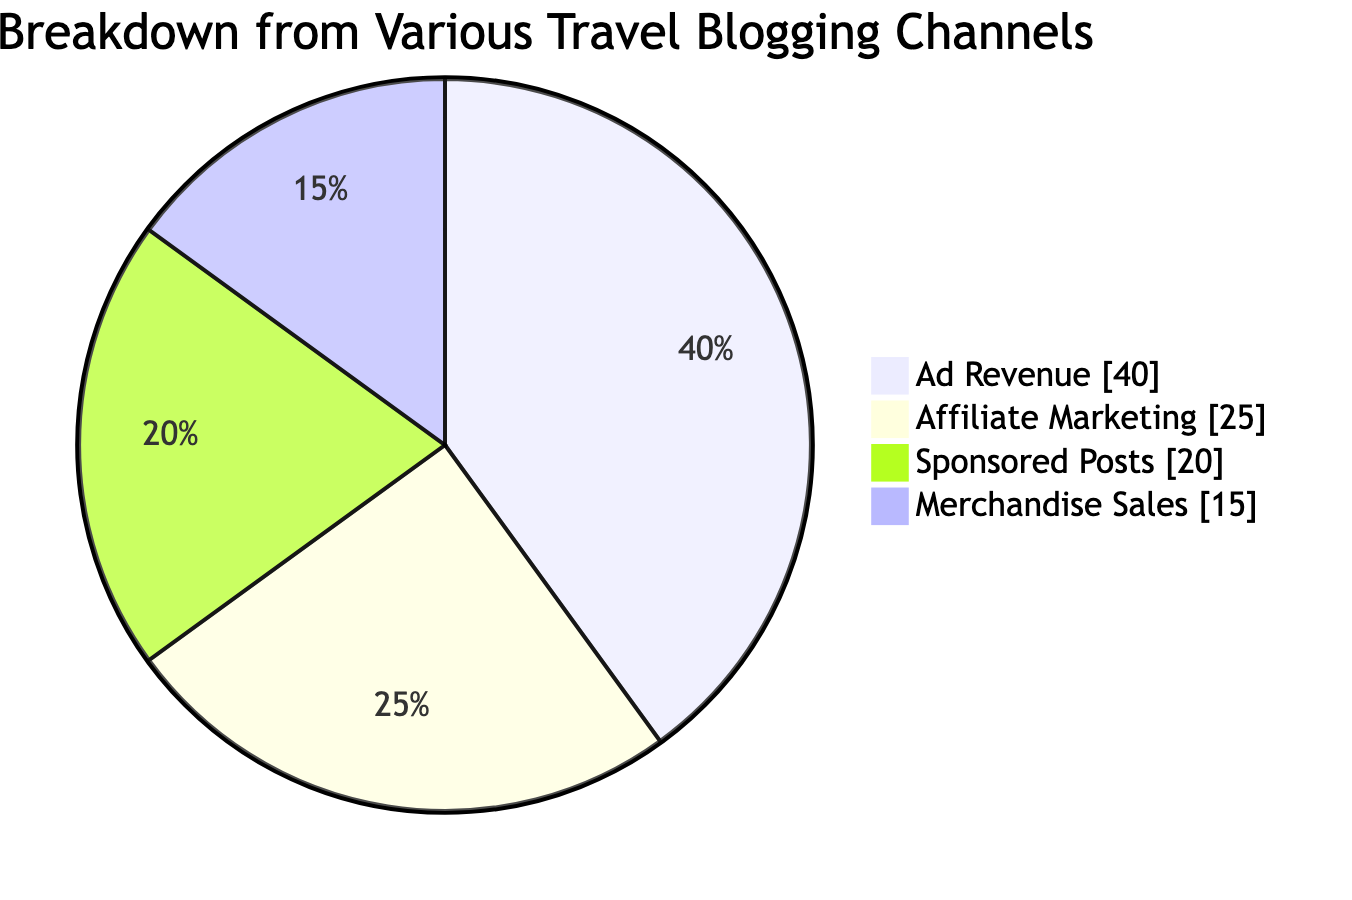What percentage of revenue comes from affiliate marketing? The diagram shows that affiliate marketing occupies one of the slices labeled "Affiliate Marketing". The slice is marked with a percentage value of 25%.
Answer: 25% Which source of revenue has the largest proportion? By inspecting the pie chart, the largest slice corresponds to "Ad Revenue", which is indicated by having the highest percentage among the slices. The value is 40%.
Answer: Ad Revenue What is the total number of revenue sources represented in the diagram? The diagram lists four distinct revenue sources: Ad Revenue, Affiliate Marketing, Sponsored Posts, and Merchandise Sales. Therefore, counting these gives a total of four.
Answer: 4 What percentage of the total revenue do sponsored posts represent? The slice "Sponsored Posts" in the diagram is marked with a percentage of 20%. This value directly answers the question about that specific revenue source.
Answer: 20% If merchandise sales were to increase by 10%, what would their new percentage be? Starting with the current value for merchandise sales of 15%, if this were to increase by 10%, the calculation would be 15% + 10% = 25%. This gives us the new percentage of merchandise sales.
Answer: 25% What is the combined percentage of revenue from ad revenue and sponsored posts? To determine the combined percentage, we add the values from these two slices: Ad Revenue (40%) + Sponsored Posts (20%) gives 60%. Thus, the combined percentage is derived from this summation.
Answer: 60% Which revenue source is represented by the smallest slice? Among the four sources in the diagram, "Merchandise Sales" shows the smallest slice with a percentage of 15%. It is visually the least prominent in the chart.
Answer: Merchandise Sales How many of the revenue sources contribute more than 15%? Inspecting the percentages of each source, we have Ad Revenue (40%), Affiliate Marketing (25%), Sponsored Posts (20%), and Merchandise Sales (15%). Here, Ad Revenue, Affiliate Marketing, and Sponsored Posts all exceed 15%, making a total of three such sources.
Answer: 3 